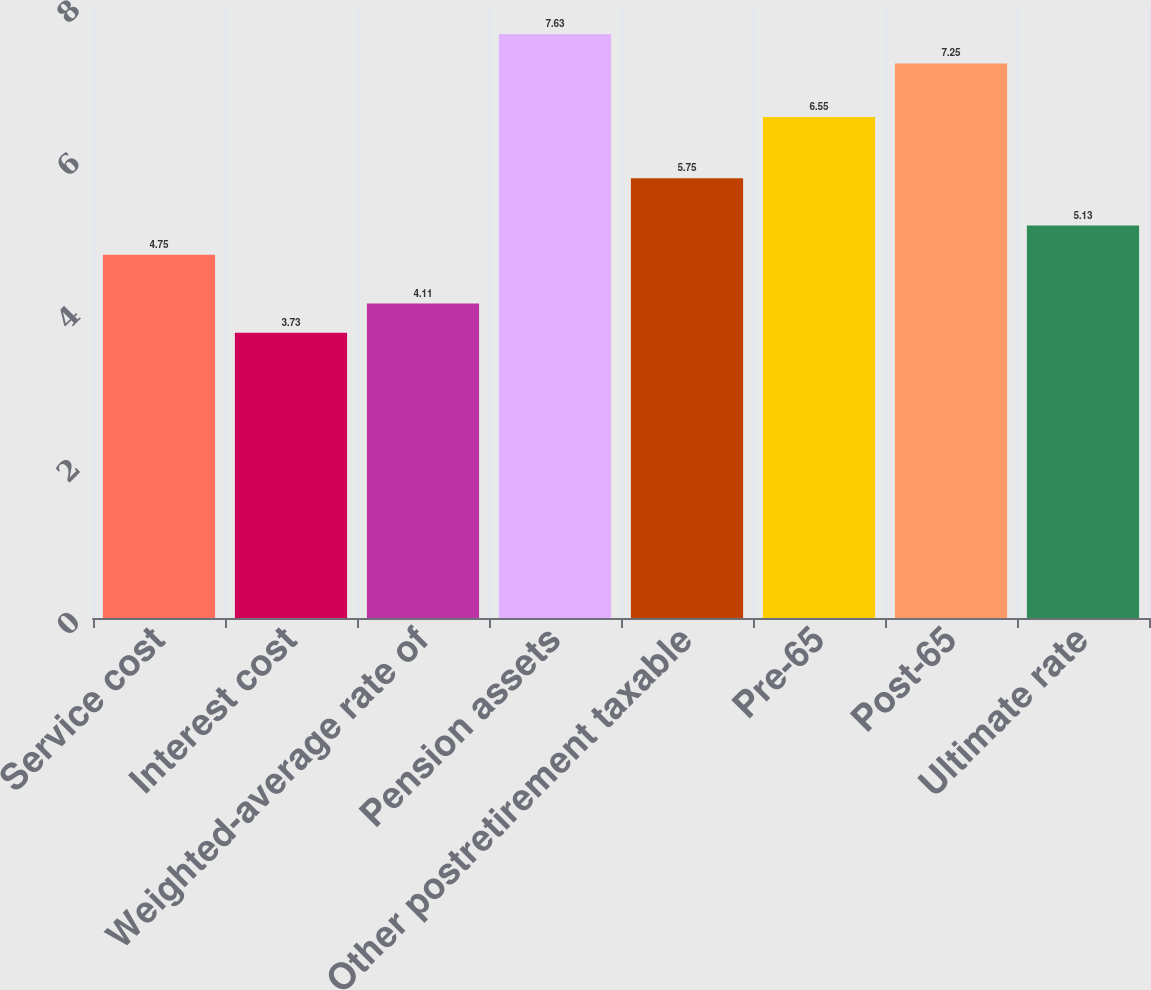Convert chart. <chart><loc_0><loc_0><loc_500><loc_500><bar_chart><fcel>Service cost<fcel>Interest cost<fcel>Weighted-average rate of<fcel>Pension assets<fcel>Other postretirement taxable<fcel>Pre-65<fcel>Post-65<fcel>Ultimate rate<nl><fcel>4.75<fcel>3.73<fcel>4.11<fcel>7.63<fcel>5.75<fcel>6.55<fcel>7.25<fcel>5.13<nl></chart> 